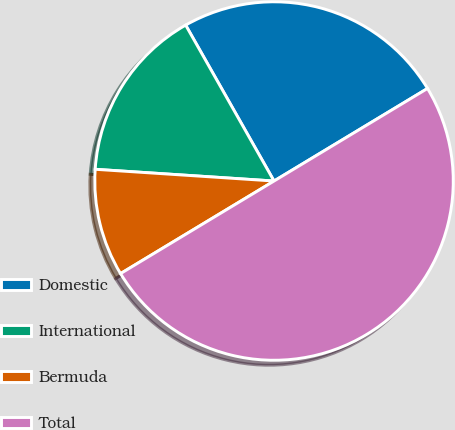Convert chart to OTSL. <chart><loc_0><loc_0><loc_500><loc_500><pie_chart><fcel>Domestic<fcel>International<fcel>Bermuda<fcel>Total<nl><fcel>24.57%<fcel>15.75%<fcel>9.68%<fcel>50.0%<nl></chart> 